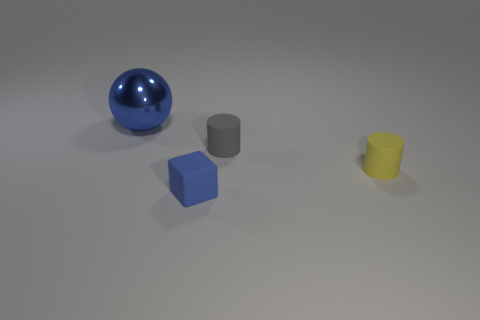Are there more yellow matte things that are behind the small gray thing than small blue rubber things on the right side of the small yellow thing?
Offer a terse response. No. What size is the blue metal thing?
Ensure brevity in your answer.  Large. What shape is the blue thing that is behind the blue rubber thing?
Provide a short and direct response. Sphere. Is the big metallic thing the same shape as the gray rubber object?
Your answer should be very brief. No. Are there the same number of rubber cubes behind the ball and yellow objects?
Provide a short and direct response. No. The yellow matte thing is what shape?
Your response must be concise. Cylinder. Is there any other thing of the same color as the shiny thing?
Offer a terse response. Yes. There is a cylinder on the left side of the yellow matte cylinder; is its size the same as the rubber cylinder that is on the right side of the small gray rubber thing?
Provide a succinct answer. Yes. There is a object to the left of the blue object in front of the large thing; what shape is it?
Your answer should be compact. Sphere. There is a gray object; is it the same size as the thing to the left of the blue cube?
Give a very brief answer. No. 